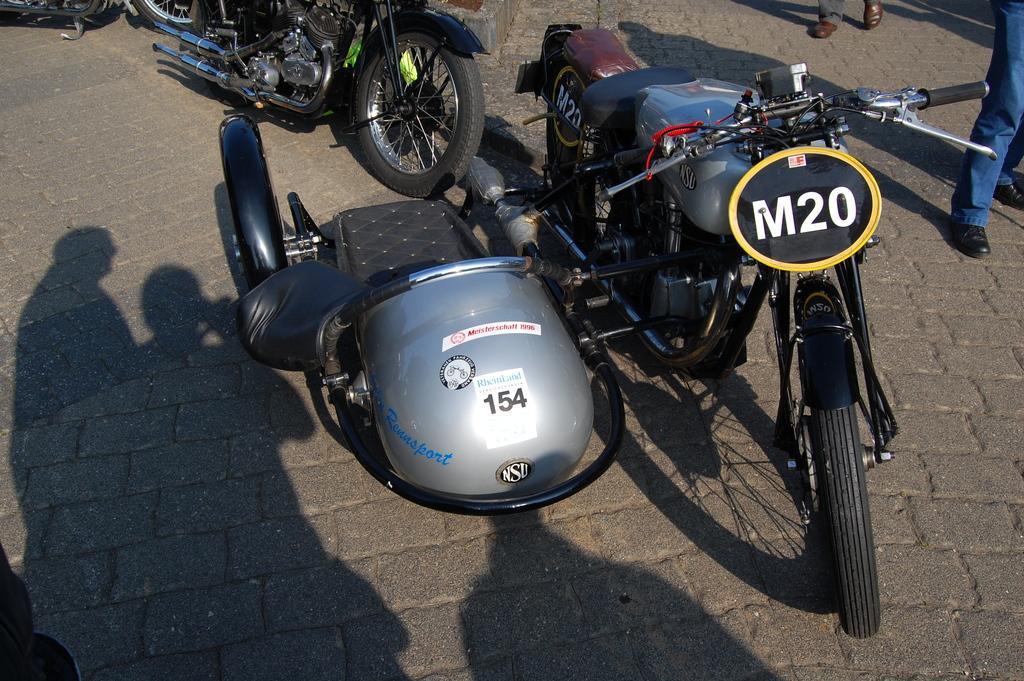Can you describe this image briefly? We can see likes on surface and we can see shadow of persons. Right side of the image we can see persons legs. 